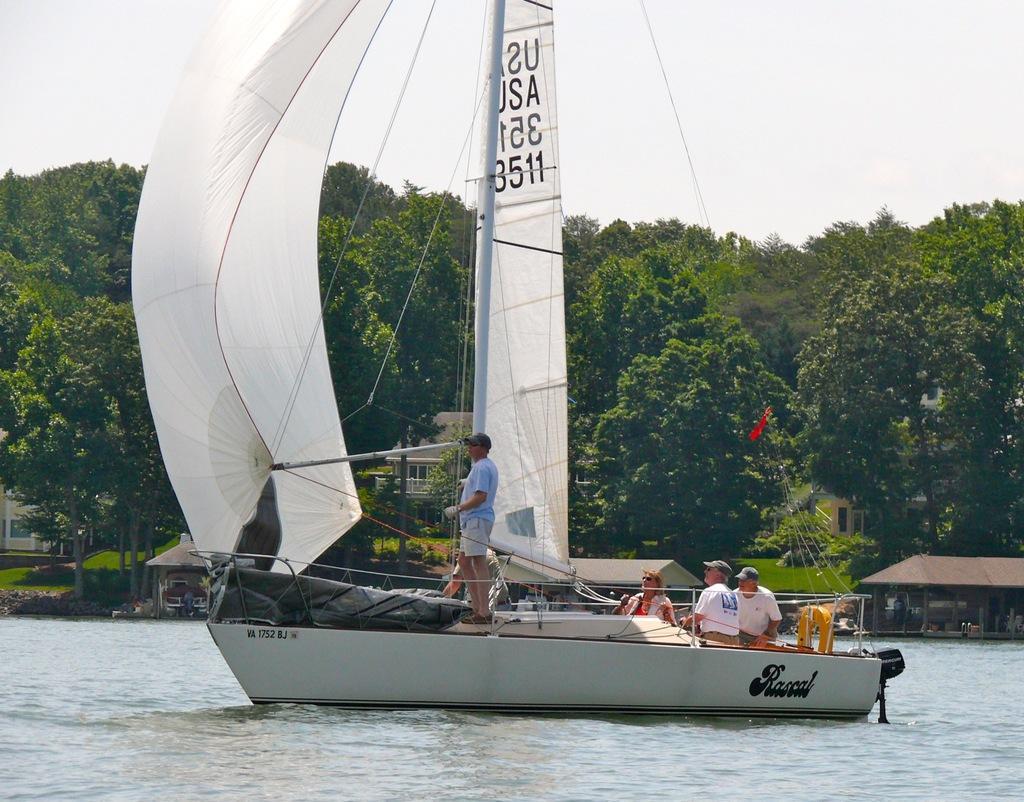In one or two sentences, can you explain what this image depicts? In this image we can see people on the boat. Here we can see water, houses, grass, plants, and trees. In the background there is sky. 